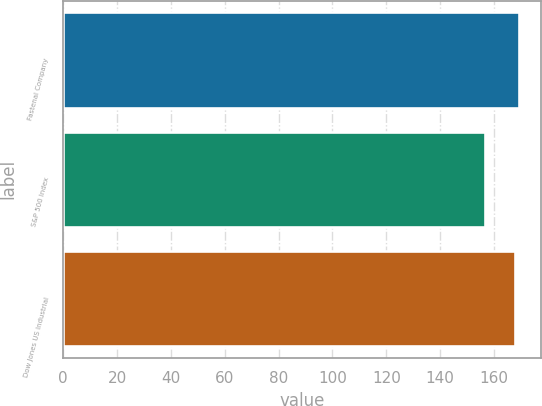<chart> <loc_0><loc_0><loc_500><loc_500><bar_chart><fcel>Fastenal Company<fcel>S&P 500 Index<fcel>Dow Jones US Industrial<nl><fcel>169.18<fcel>156.82<fcel>167.88<nl></chart> 